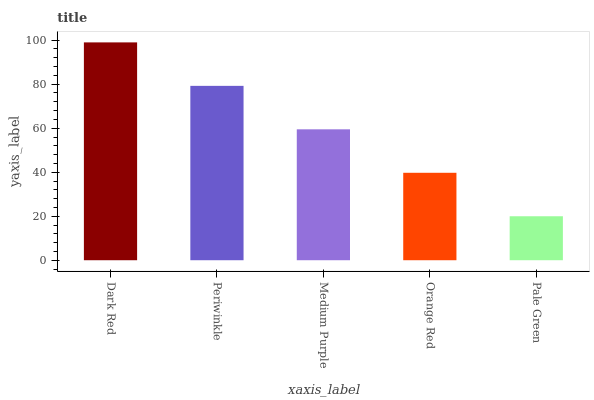Is Pale Green the minimum?
Answer yes or no. Yes. Is Dark Red the maximum?
Answer yes or no. Yes. Is Periwinkle the minimum?
Answer yes or no. No. Is Periwinkle the maximum?
Answer yes or no. No. Is Dark Red greater than Periwinkle?
Answer yes or no. Yes. Is Periwinkle less than Dark Red?
Answer yes or no. Yes. Is Periwinkle greater than Dark Red?
Answer yes or no. No. Is Dark Red less than Periwinkle?
Answer yes or no. No. Is Medium Purple the high median?
Answer yes or no. Yes. Is Medium Purple the low median?
Answer yes or no. Yes. Is Dark Red the high median?
Answer yes or no. No. Is Pale Green the low median?
Answer yes or no. No. 